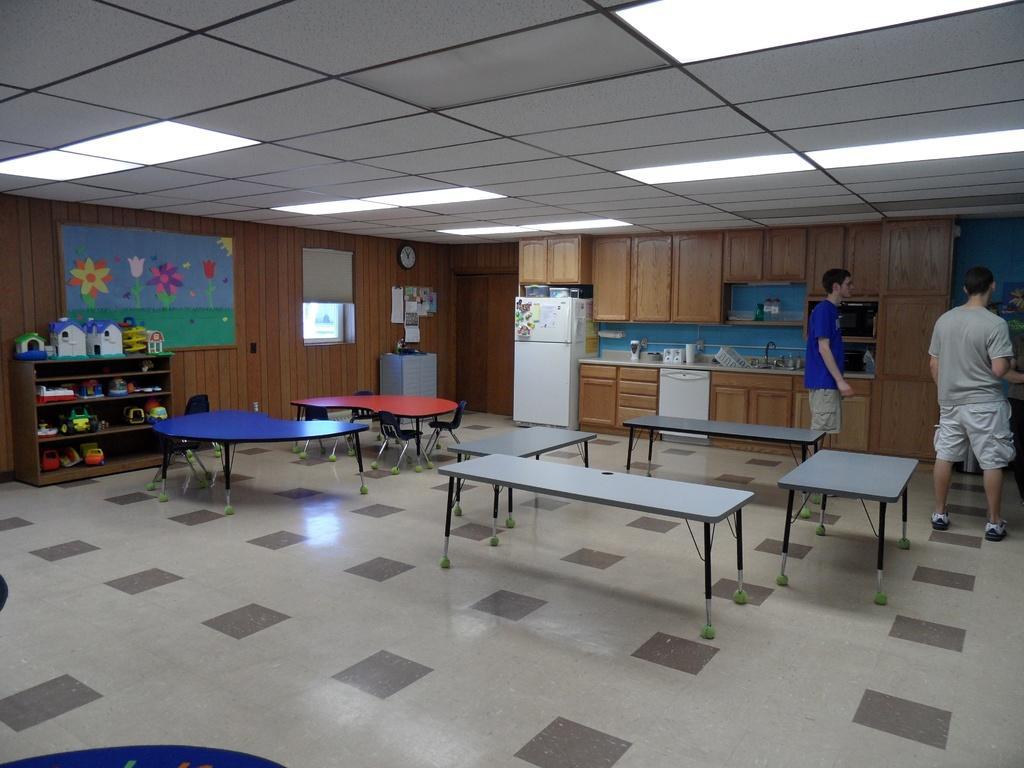Could you give a brief overview of what you see in this image? In this image we can see a few tables, a shelf and few objects on the shelf, there is a fridge, cupboards, a picture to the wall, two people, a few objects in a room and lights to the ceiling. 